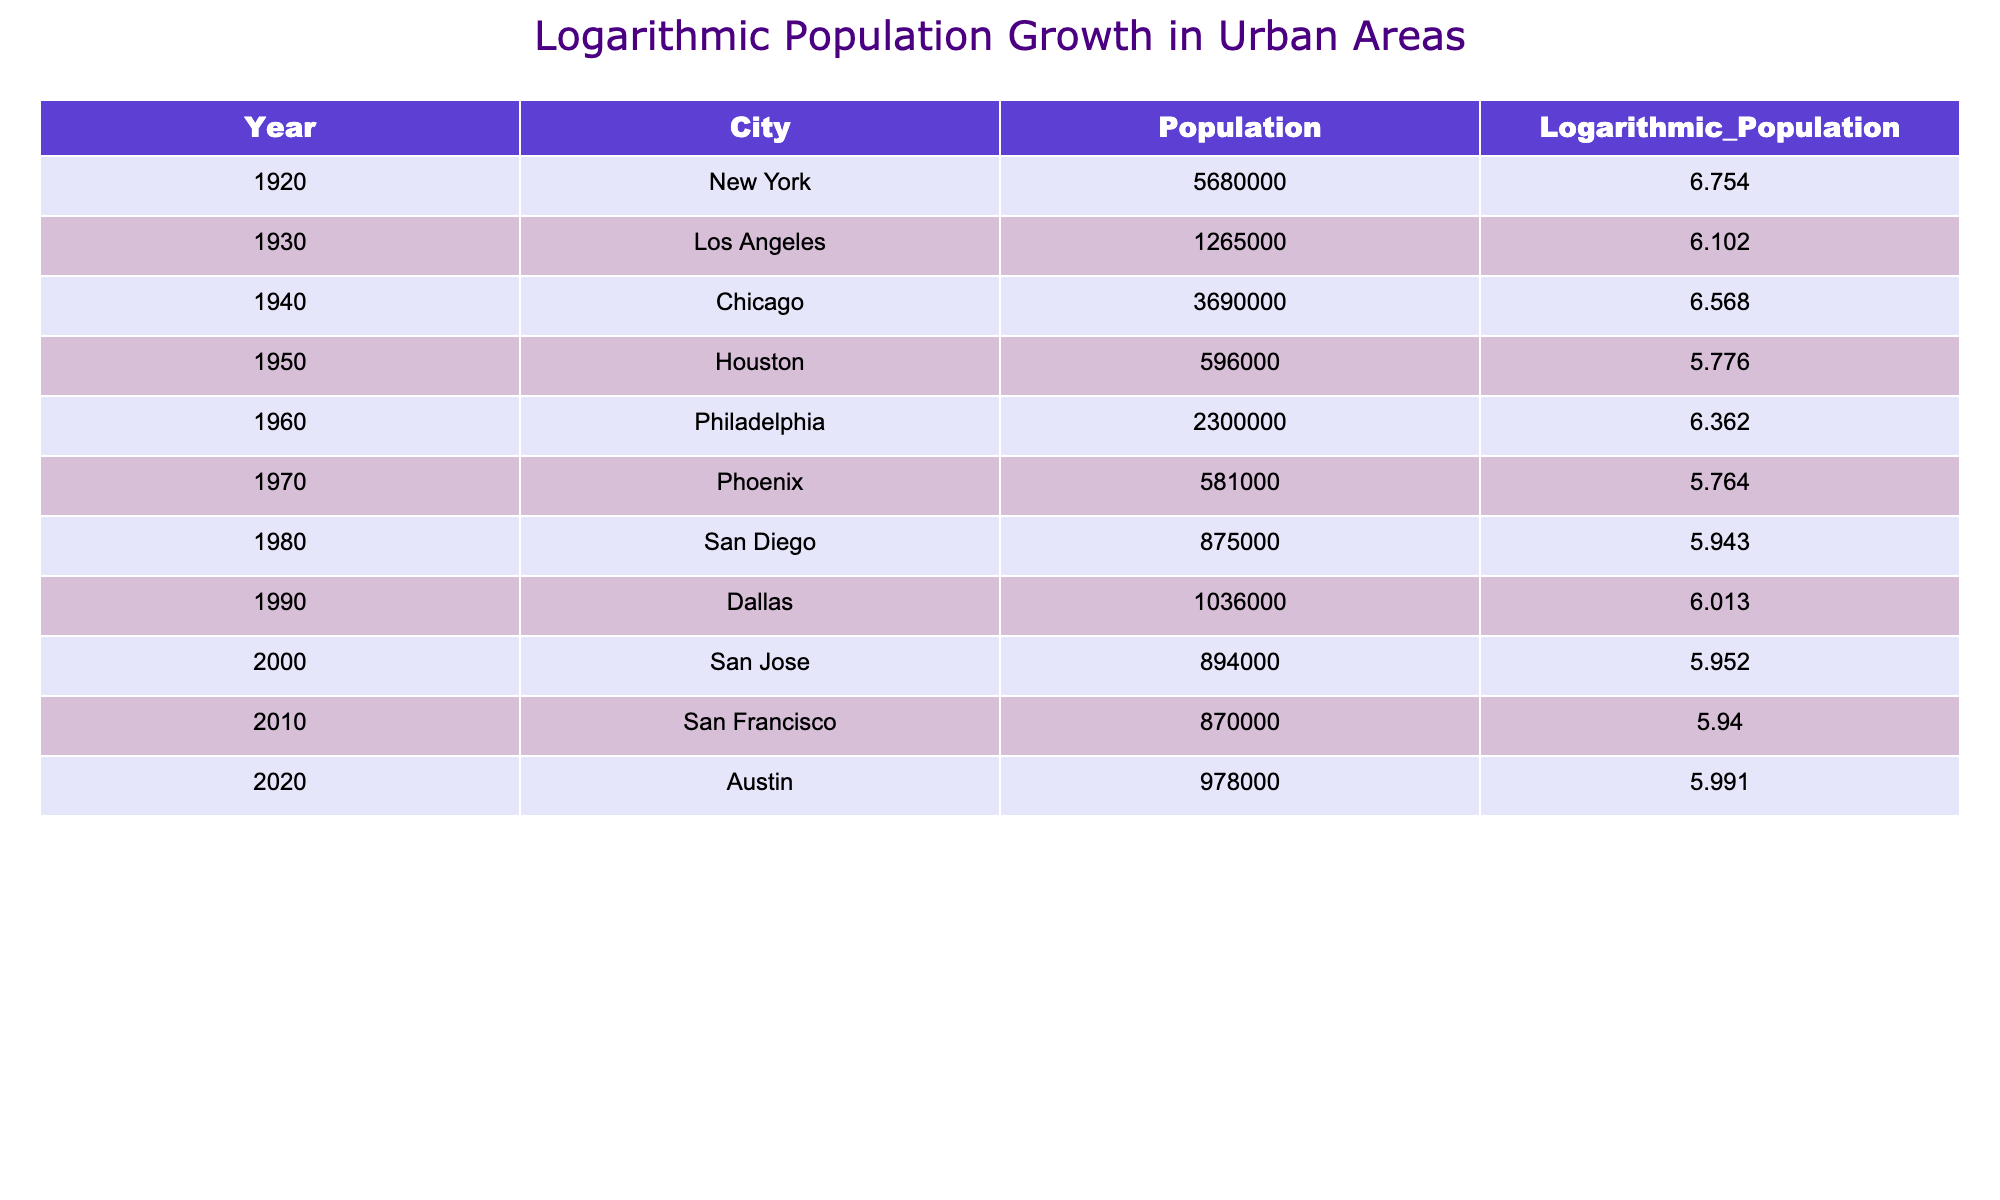What is the population of New York in 1920? The table shows that in the year 1920, New York had a population of 5,680,000. This value is directly retrieved from the table.
Answer: 5,680,000 Which city had the highest population growth between 1920 and 1930? To determine the city with the highest growth from 1920 to 1930, we compare the populations: New York (5,680,000) and Los Angeles (1,265,000). The change is (1,265,000 - 5,680,000) < 0, meaning Los Angeles did not grow. The only positive growth was for cities starting after 1920, but since only Los Angeles had data, there is no growth compared to New York.
Answer: No growth What is the logarithmic population of Chicago in 1940? The table indicates that in 1940, Chicago's logarithmic population is 6.568. This value can be seen directly in the table.
Answer: 6.568 How many cities had a population greater than 1 million in the year 2000? By examining the table, in the year 2000, we have San Jose with 894,000, which is less than 1 million. Looking upward, only New York, Chicago, Los Angeles, and Dallas have above 1 million from previous years. Therefore, the answer is zero.
Answer: 0 What was the average logarithmic population from 1920 to 2020 for the cities listed? To find the average, we calculate the logarithmic populations as follows: (6.754 + 6.102 + 6.568 + 5.776 + 6.362 + 5.764 + 5.943 + 6.013 + 5.952 + 5.940 + 5.991) = 66.909. There are 11 data points. To find the average, we divide the total (66.909) by the number of data points (11), which is approximately 6.090.
Answer: 6.090 Did the population of Houston increase or decrease from 1950 to 1960? Comparing the populations in the years 1950 and 1960, Houston had a population of 596,000 in 1950 and Philadelphia (not Houston) 2,300,000 in 1960, which shows an increase in urban areas but not for Houston specifically, which is the focus here. Hence the direct comparison shows no increase.
Answer: Decrease 